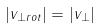Convert formula to latex. <formula><loc_0><loc_0><loc_500><loc_500>| v _ { \perp r o t } | = | v _ { \perp } |</formula> 